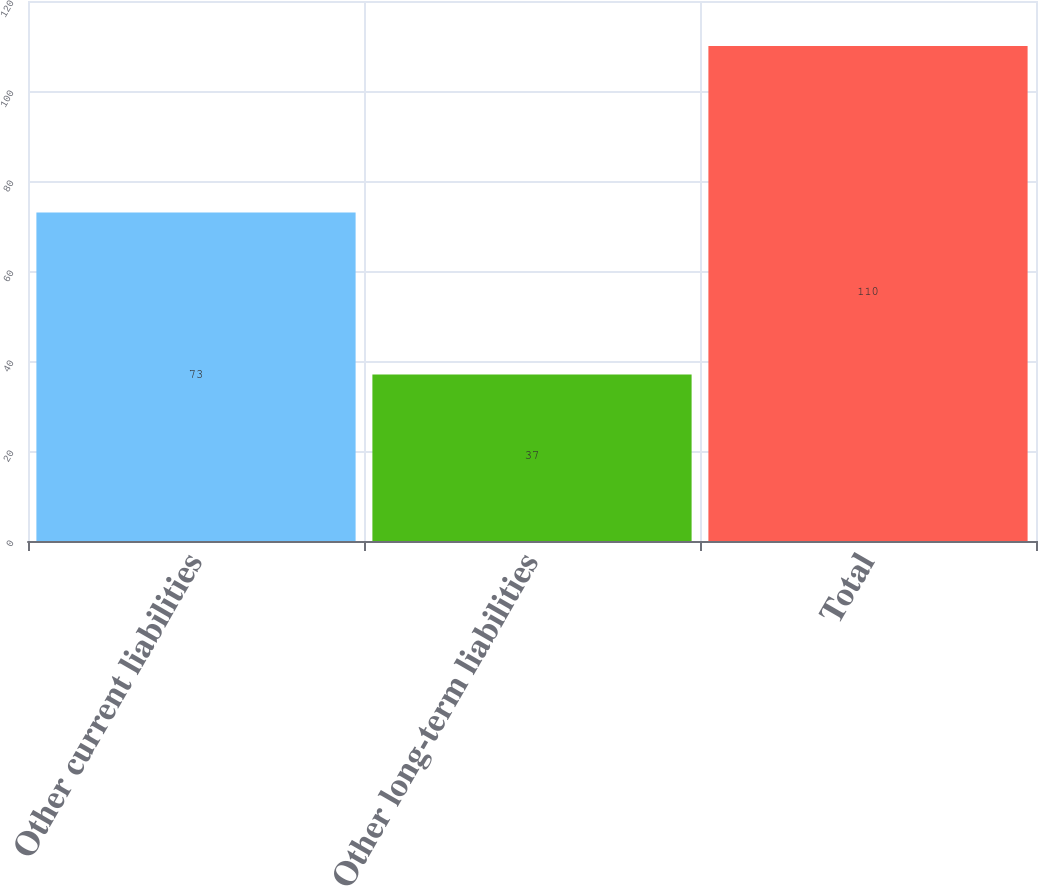<chart> <loc_0><loc_0><loc_500><loc_500><bar_chart><fcel>Other current liabilities<fcel>Other long-term liabilities<fcel>Total<nl><fcel>73<fcel>37<fcel>110<nl></chart> 